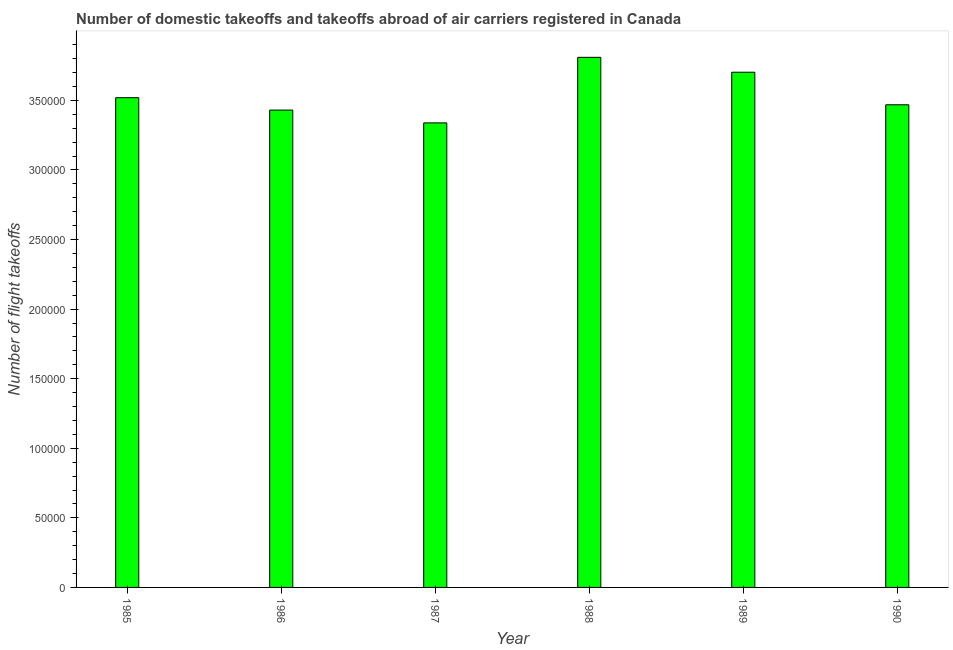What is the title of the graph?
Your response must be concise. Number of domestic takeoffs and takeoffs abroad of air carriers registered in Canada. What is the label or title of the X-axis?
Offer a very short reply. Year. What is the label or title of the Y-axis?
Your response must be concise. Number of flight takeoffs. What is the number of flight takeoffs in 1986?
Keep it short and to the point. 3.43e+05. Across all years, what is the maximum number of flight takeoffs?
Keep it short and to the point. 3.81e+05. Across all years, what is the minimum number of flight takeoffs?
Make the answer very short. 3.34e+05. In which year was the number of flight takeoffs maximum?
Offer a very short reply. 1988. What is the sum of the number of flight takeoffs?
Your response must be concise. 2.13e+06. What is the difference between the number of flight takeoffs in 1985 and 1986?
Offer a terse response. 8900. What is the average number of flight takeoffs per year?
Give a very brief answer. 3.54e+05. What is the median number of flight takeoffs?
Your answer should be very brief. 3.49e+05. What is the difference between the highest and the second highest number of flight takeoffs?
Your response must be concise. 1.07e+04. What is the difference between the highest and the lowest number of flight takeoffs?
Your response must be concise. 4.71e+04. How many bars are there?
Provide a short and direct response. 6. What is the difference between two consecutive major ticks on the Y-axis?
Make the answer very short. 5.00e+04. What is the Number of flight takeoffs in 1985?
Give a very brief answer. 3.52e+05. What is the Number of flight takeoffs in 1986?
Give a very brief answer. 3.43e+05. What is the Number of flight takeoffs in 1987?
Keep it short and to the point. 3.34e+05. What is the Number of flight takeoffs in 1988?
Offer a terse response. 3.81e+05. What is the Number of flight takeoffs of 1989?
Make the answer very short. 3.70e+05. What is the Number of flight takeoffs in 1990?
Provide a succinct answer. 3.47e+05. What is the difference between the Number of flight takeoffs in 1985 and 1986?
Provide a succinct answer. 8900. What is the difference between the Number of flight takeoffs in 1985 and 1987?
Give a very brief answer. 1.81e+04. What is the difference between the Number of flight takeoffs in 1985 and 1988?
Give a very brief answer. -2.90e+04. What is the difference between the Number of flight takeoffs in 1985 and 1989?
Offer a terse response. -1.83e+04. What is the difference between the Number of flight takeoffs in 1985 and 1990?
Your response must be concise. 5100. What is the difference between the Number of flight takeoffs in 1986 and 1987?
Give a very brief answer. 9200. What is the difference between the Number of flight takeoffs in 1986 and 1988?
Provide a succinct answer. -3.79e+04. What is the difference between the Number of flight takeoffs in 1986 and 1989?
Your answer should be compact. -2.72e+04. What is the difference between the Number of flight takeoffs in 1986 and 1990?
Keep it short and to the point. -3800. What is the difference between the Number of flight takeoffs in 1987 and 1988?
Provide a succinct answer. -4.71e+04. What is the difference between the Number of flight takeoffs in 1987 and 1989?
Ensure brevity in your answer.  -3.64e+04. What is the difference between the Number of flight takeoffs in 1987 and 1990?
Offer a terse response. -1.30e+04. What is the difference between the Number of flight takeoffs in 1988 and 1989?
Provide a succinct answer. 1.07e+04. What is the difference between the Number of flight takeoffs in 1988 and 1990?
Provide a succinct answer. 3.41e+04. What is the difference between the Number of flight takeoffs in 1989 and 1990?
Give a very brief answer. 2.34e+04. What is the ratio of the Number of flight takeoffs in 1985 to that in 1986?
Give a very brief answer. 1.03. What is the ratio of the Number of flight takeoffs in 1985 to that in 1987?
Your answer should be compact. 1.05. What is the ratio of the Number of flight takeoffs in 1985 to that in 1988?
Give a very brief answer. 0.92. What is the ratio of the Number of flight takeoffs in 1985 to that in 1989?
Keep it short and to the point. 0.95. What is the ratio of the Number of flight takeoffs in 1985 to that in 1990?
Make the answer very short. 1.01. What is the ratio of the Number of flight takeoffs in 1986 to that in 1987?
Make the answer very short. 1.03. What is the ratio of the Number of flight takeoffs in 1986 to that in 1988?
Your answer should be compact. 0.9. What is the ratio of the Number of flight takeoffs in 1986 to that in 1989?
Offer a terse response. 0.93. What is the ratio of the Number of flight takeoffs in 1987 to that in 1988?
Your answer should be very brief. 0.88. What is the ratio of the Number of flight takeoffs in 1987 to that in 1989?
Offer a terse response. 0.9. What is the ratio of the Number of flight takeoffs in 1987 to that in 1990?
Your response must be concise. 0.96. What is the ratio of the Number of flight takeoffs in 1988 to that in 1990?
Your answer should be very brief. 1.1. What is the ratio of the Number of flight takeoffs in 1989 to that in 1990?
Your answer should be compact. 1.07. 